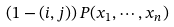<formula> <loc_0><loc_0><loc_500><loc_500>\left ( 1 - ( i , j ) \right ) P ( x _ { 1 } , \cdots , x _ { n } )</formula> 